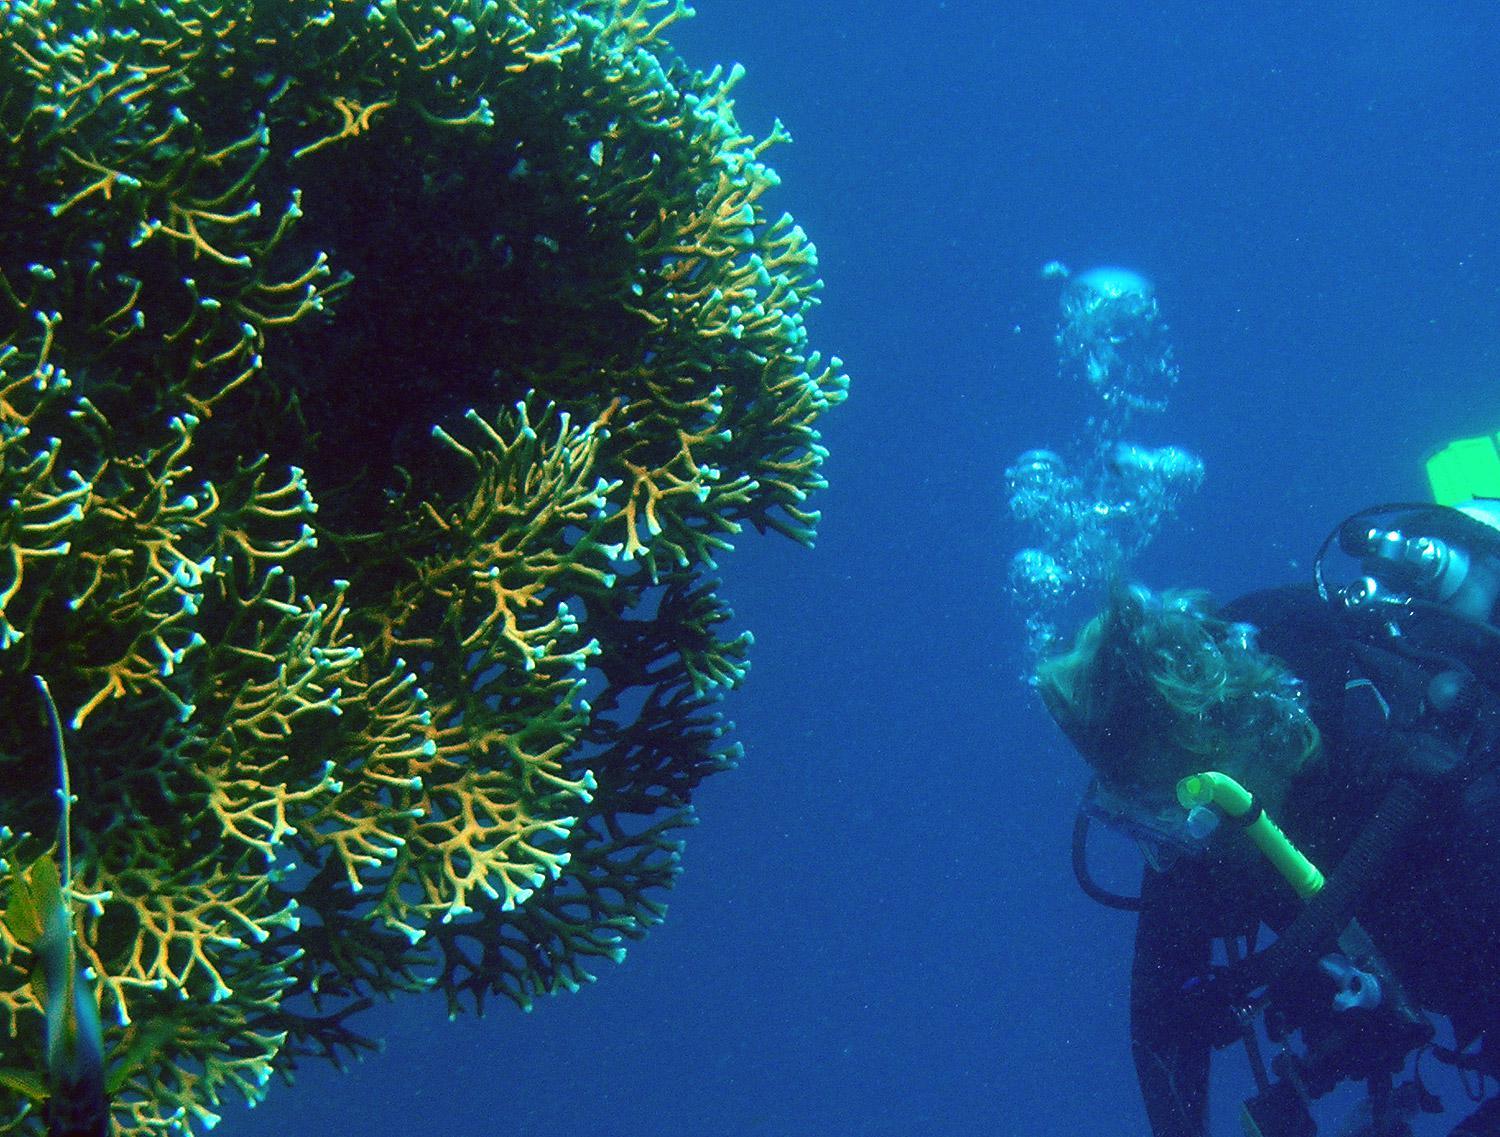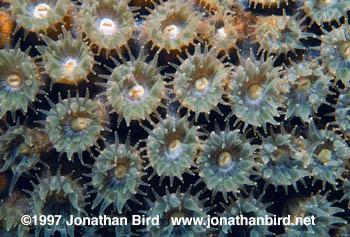The first image is the image on the left, the second image is the image on the right. Assess this claim about the two images: "IN at least one image there is at least 10 circled yellow and brown corral  arms facing forward.". Correct or not? Answer yes or no. Yes. The first image is the image on the left, the second image is the image on the right. Assess this claim about the two images: "One image shows a mass of flower-shaped anemone with flatter white centers surrounded by slender tendrils.". Correct or not? Answer yes or no. Yes. 